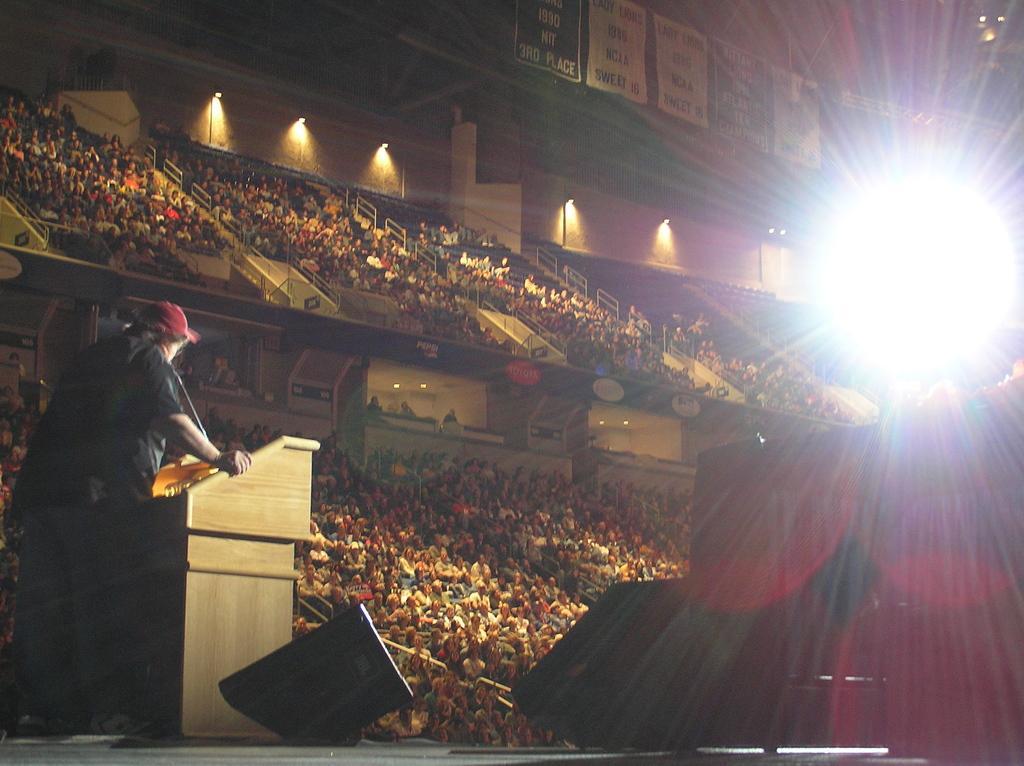How would you summarize this image in a sentence or two? This image is taken in an auditorium. In this image we can see many people sitting. On the left there is a person standing in front of a podium on the stage. Image also consists of lights and also banners at the top. 